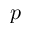<formula> <loc_0><loc_0><loc_500><loc_500>p</formula> 